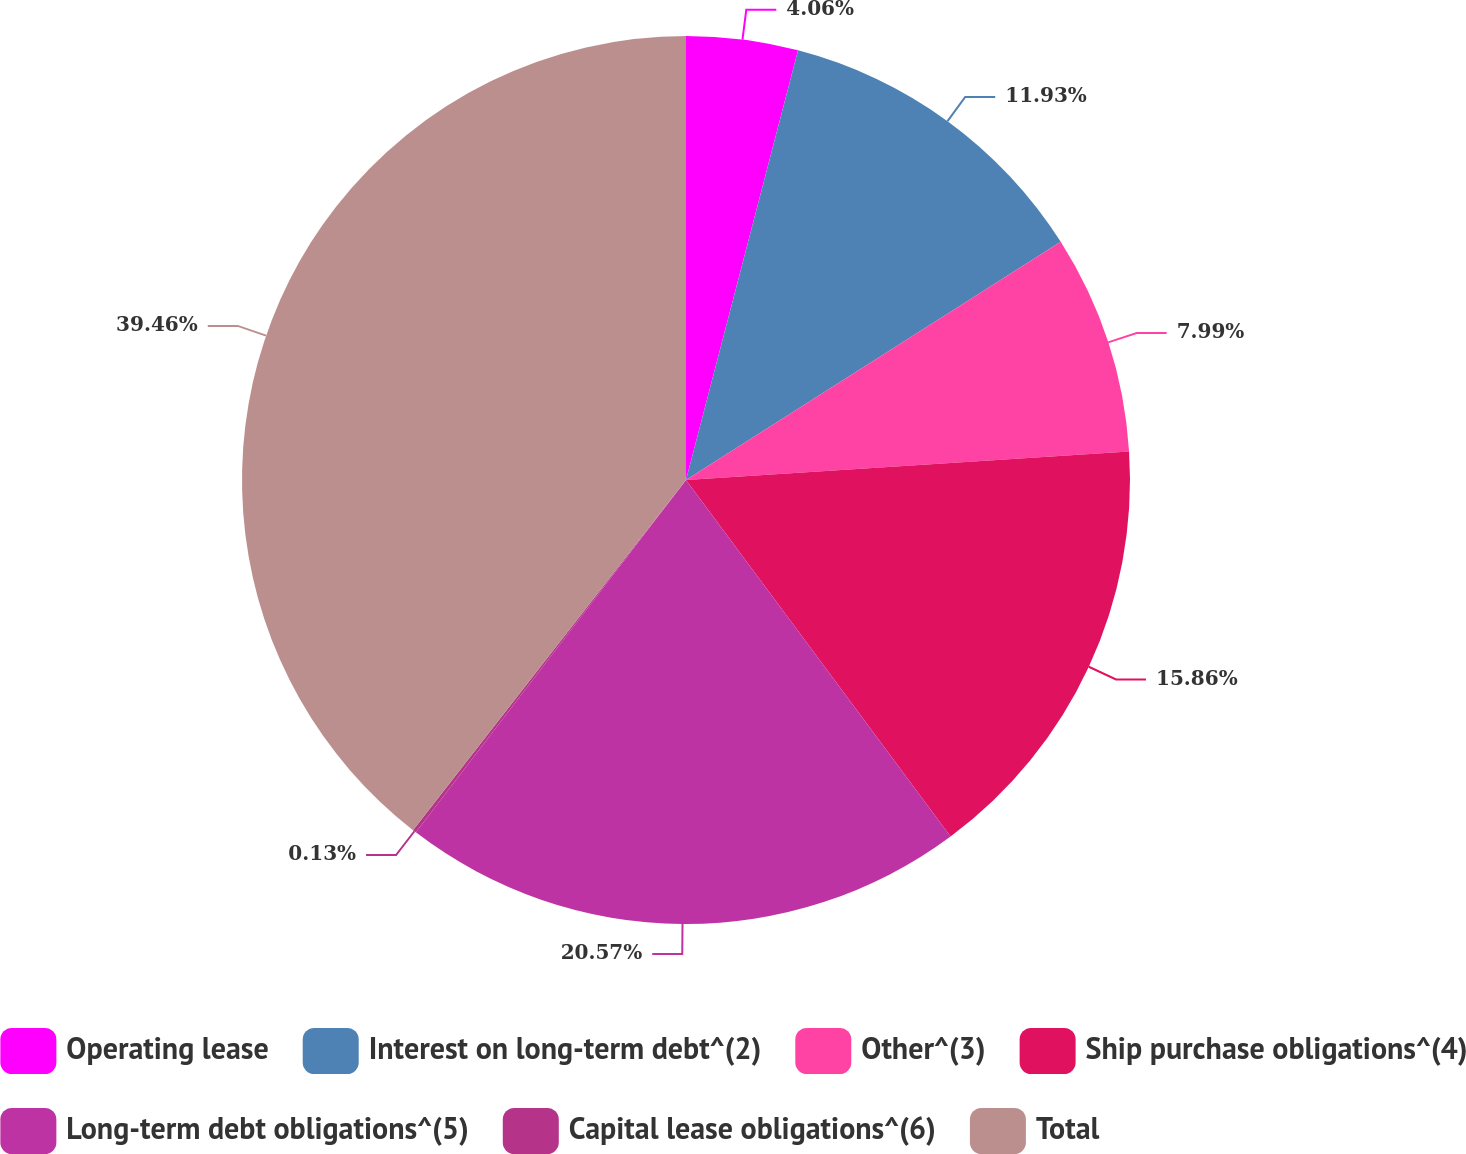Convert chart to OTSL. <chart><loc_0><loc_0><loc_500><loc_500><pie_chart><fcel>Operating lease<fcel>Interest on long-term debt^(2)<fcel>Other^(3)<fcel>Ship purchase obligations^(4)<fcel>Long-term debt obligations^(5)<fcel>Capital lease obligations^(6)<fcel>Total<nl><fcel>4.06%<fcel>11.93%<fcel>7.99%<fcel>15.86%<fcel>20.57%<fcel>0.13%<fcel>39.46%<nl></chart> 